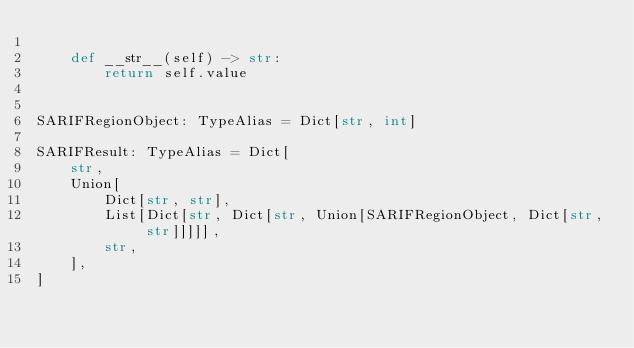Convert code to text. <code><loc_0><loc_0><loc_500><loc_500><_Python_>
    def __str__(self) -> str:
        return self.value


SARIFRegionObject: TypeAlias = Dict[str, int]

SARIFResult: TypeAlias = Dict[
    str,
    Union[
        Dict[str, str],
        List[Dict[str, Dict[str, Union[SARIFRegionObject, Dict[str, str]]]]],
        str,
    ],
]
</code> 